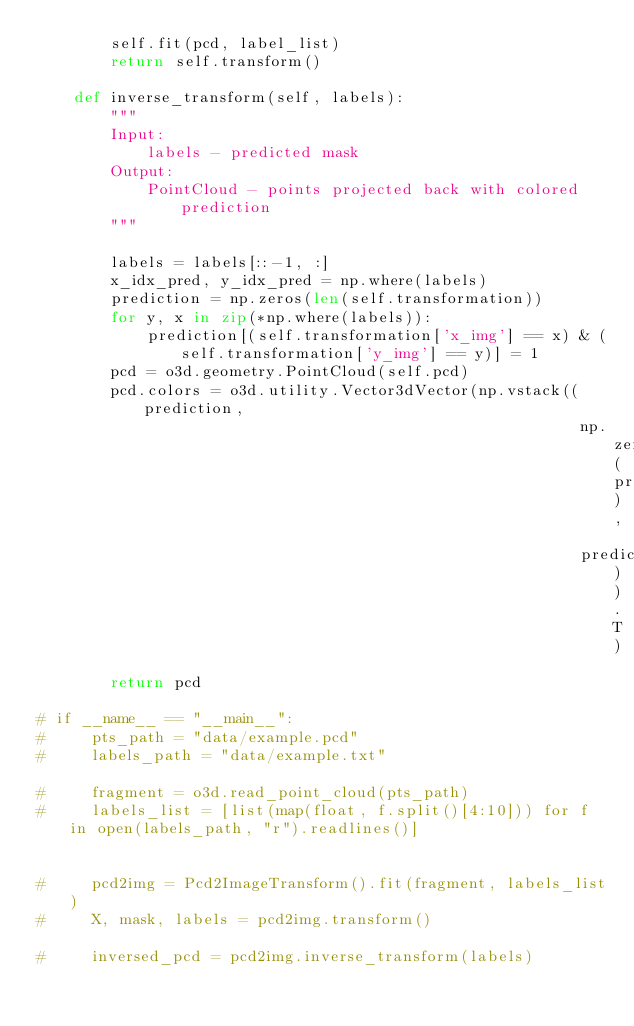<code> <loc_0><loc_0><loc_500><loc_500><_Python_>        self.fit(pcd, label_list)
        return self.transform()
    
    def inverse_transform(self, labels):
        """
        Input: 
            labels - predicted mask
        Output:
            PointCloud - points projected back with colored prediction
        """
        
        labels = labels[::-1, :]
        x_idx_pred, y_idx_pred = np.where(labels)
        prediction = np.zeros(len(self.transformation))
        for y, x in zip(*np.where(labels)):
            prediction[(self.transformation['x_img'] == x) & (self.transformation['y_img'] == y)] = 1
        pcd = o3d.geometry.PointCloud(self.pcd)
        pcd.colors = o3d.utility.Vector3dVector(np.vstack((prediction,
                                                           np.zeros_like(prediction),
                                                           prediction)).T)
        return pcd
    
# if __name__ == "__main__":
#     pts_path = "data/example.pcd"
#     labels_path = "data/example.txt"

#     fragment = o3d.read_point_cloud(pts_path)
#     labels_list = [list(map(float, f.split()[4:10])) for f in open(labels_path, "r").readlines()]


#     pcd2img = Pcd2ImageTransform().fit(fragment, labels_list)
#     X, mask, labels = pcd2img.transform()

#     inversed_pcd = pcd2img.inverse_transform(labels)

</code> 